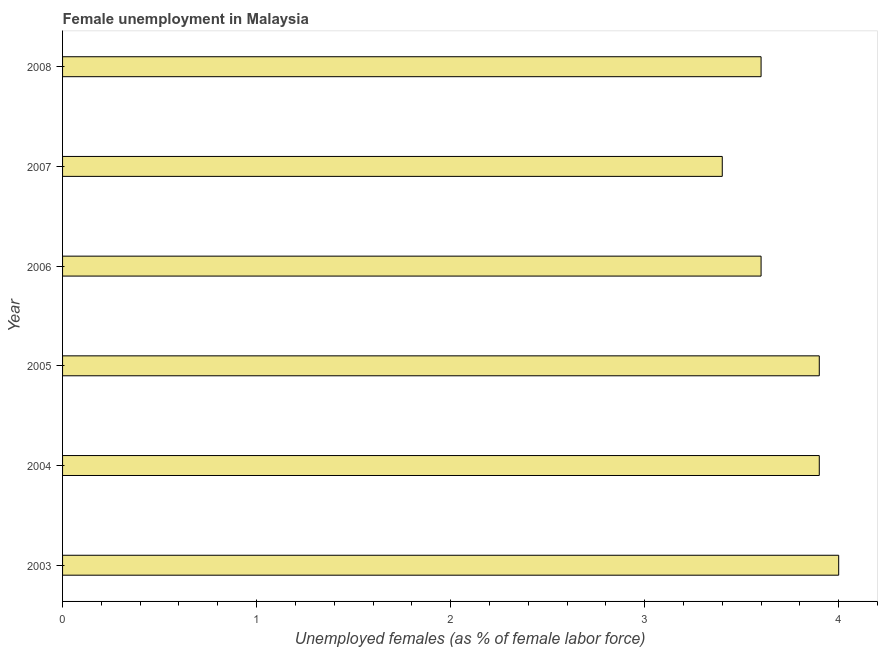Does the graph contain grids?
Ensure brevity in your answer.  No. What is the title of the graph?
Offer a very short reply. Female unemployment in Malaysia. What is the label or title of the X-axis?
Keep it short and to the point. Unemployed females (as % of female labor force). What is the unemployed females population in 2004?
Give a very brief answer. 3.9. Across all years, what is the minimum unemployed females population?
Make the answer very short. 3.4. What is the sum of the unemployed females population?
Ensure brevity in your answer.  22.4. What is the average unemployed females population per year?
Provide a succinct answer. 3.73. What is the median unemployed females population?
Your answer should be compact. 3.75. Do a majority of the years between 2007 and 2004 (inclusive) have unemployed females population greater than 0.2 %?
Keep it short and to the point. Yes. What is the ratio of the unemployed females population in 2006 to that in 2007?
Keep it short and to the point. 1.06. Is the unemployed females population in 2004 less than that in 2005?
Offer a terse response. No. Is the difference between the unemployed females population in 2004 and 2005 greater than the difference between any two years?
Provide a succinct answer. No. What is the difference between the highest and the second highest unemployed females population?
Provide a succinct answer. 0.1. Is the sum of the unemployed females population in 2003 and 2005 greater than the maximum unemployed females population across all years?
Your response must be concise. Yes. Are all the bars in the graph horizontal?
Keep it short and to the point. Yes. How many years are there in the graph?
Your answer should be very brief. 6. Are the values on the major ticks of X-axis written in scientific E-notation?
Your answer should be compact. No. What is the Unemployed females (as % of female labor force) of 2004?
Your response must be concise. 3.9. What is the Unemployed females (as % of female labor force) of 2005?
Provide a short and direct response. 3.9. What is the Unemployed females (as % of female labor force) of 2006?
Provide a short and direct response. 3.6. What is the Unemployed females (as % of female labor force) of 2007?
Offer a terse response. 3.4. What is the Unemployed females (as % of female labor force) in 2008?
Offer a very short reply. 3.6. What is the difference between the Unemployed females (as % of female labor force) in 2003 and 2005?
Keep it short and to the point. 0.1. What is the difference between the Unemployed females (as % of female labor force) in 2003 and 2006?
Provide a succinct answer. 0.4. What is the difference between the Unemployed females (as % of female labor force) in 2003 and 2007?
Offer a terse response. 0.6. What is the difference between the Unemployed females (as % of female labor force) in 2004 and 2007?
Provide a succinct answer. 0.5. What is the difference between the Unemployed females (as % of female labor force) in 2005 and 2006?
Make the answer very short. 0.3. What is the difference between the Unemployed females (as % of female labor force) in 2005 and 2007?
Provide a short and direct response. 0.5. What is the difference between the Unemployed females (as % of female labor force) in 2005 and 2008?
Give a very brief answer. 0.3. What is the difference between the Unemployed females (as % of female labor force) in 2006 and 2007?
Keep it short and to the point. 0.2. What is the difference between the Unemployed females (as % of female labor force) in 2006 and 2008?
Give a very brief answer. 0. What is the ratio of the Unemployed females (as % of female labor force) in 2003 to that in 2004?
Ensure brevity in your answer.  1.03. What is the ratio of the Unemployed females (as % of female labor force) in 2003 to that in 2005?
Provide a succinct answer. 1.03. What is the ratio of the Unemployed females (as % of female labor force) in 2003 to that in 2006?
Your answer should be compact. 1.11. What is the ratio of the Unemployed females (as % of female labor force) in 2003 to that in 2007?
Make the answer very short. 1.18. What is the ratio of the Unemployed females (as % of female labor force) in 2003 to that in 2008?
Make the answer very short. 1.11. What is the ratio of the Unemployed females (as % of female labor force) in 2004 to that in 2005?
Keep it short and to the point. 1. What is the ratio of the Unemployed females (as % of female labor force) in 2004 to that in 2006?
Ensure brevity in your answer.  1.08. What is the ratio of the Unemployed females (as % of female labor force) in 2004 to that in 2007?
Your answer should be compact. 1.15. What is the ratio of the Unemployed females (as % of female labor force) in 2004 to that in 2008?
Make the answer very short. 1.08. What is the ratio of the Unemployed females (as % of female labor force) in 2005 to that in 2006?
Give a very brief answer. 1.08. What is the ratio of the Unemployed females (as % of female labor force) in 2005 to that in 2007?
Keep it short and to the point. 1.15. What is the ratio of the Unemployed females (as % of female labor force) in 2005 to that in 2008?
Your answer should be compact. 1.08. What is the ratio of the Unemployed females (as % of female labor force) in 2006 to that in 2007?
Offer a terse response. 1.06. What is the ratio of the Unemployed females (as % of female labor force) in 2006 to that in 2008?
Provide a succinct answer. 1. What is the ratio of the Unemployed females (as % of female labor force) in 2007 to that in 2008?
Offer a terse response. 0.94. 